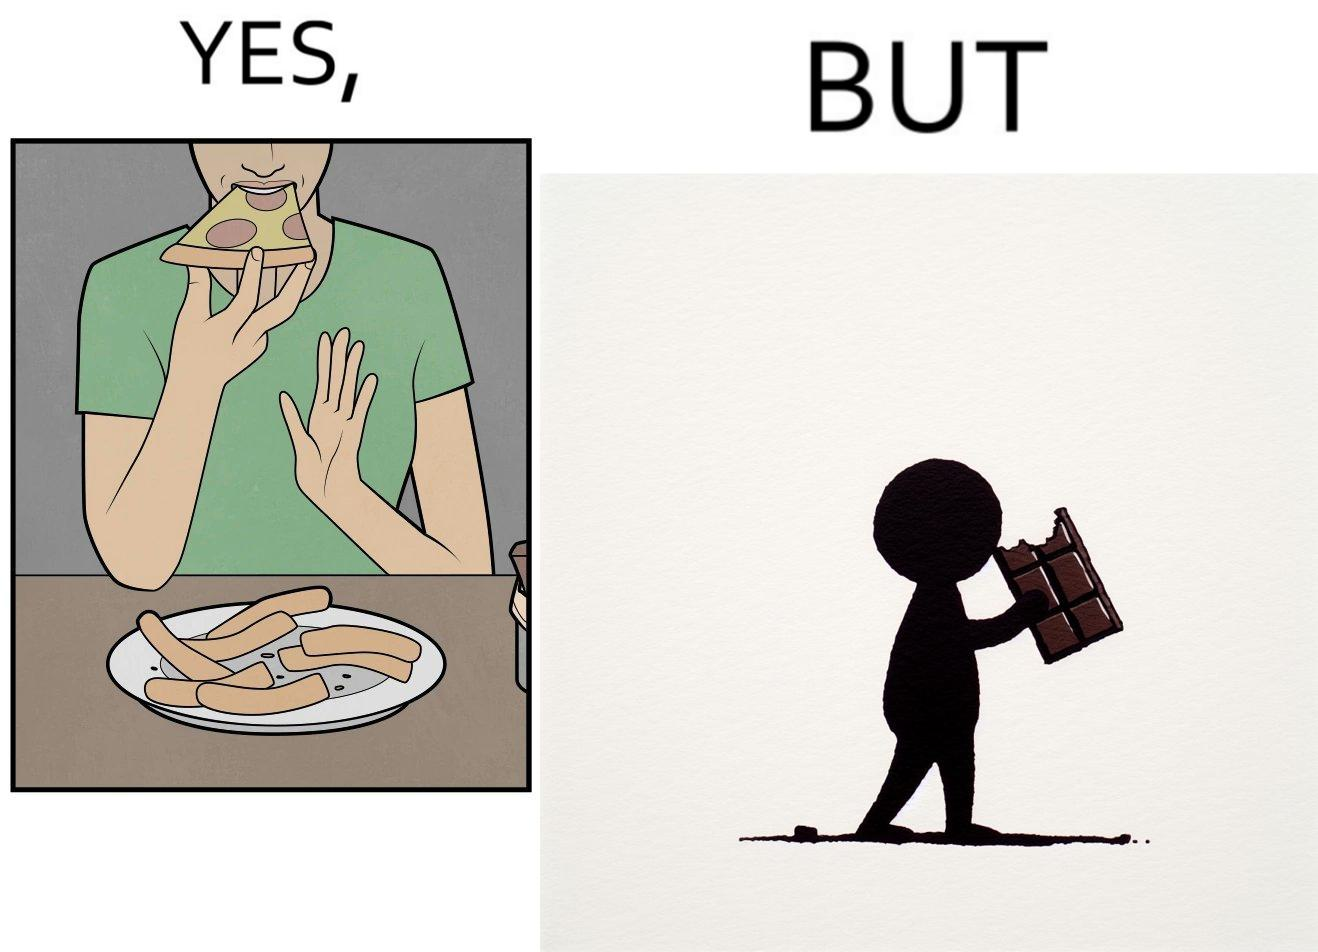Describe the content of this image. the irony in this image is that people waste pizza crust by saying that it is too hard, while they eat hard chocolate without any complaints 